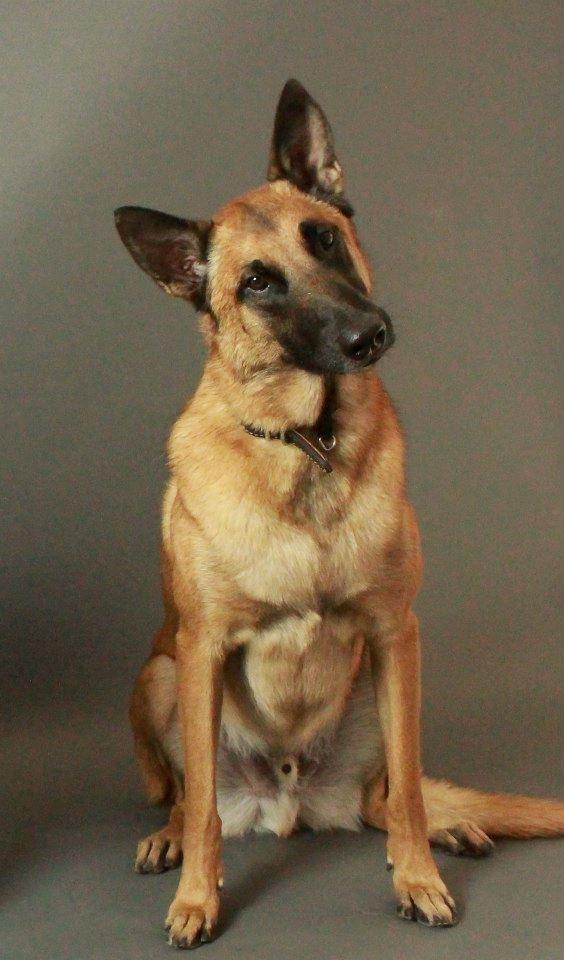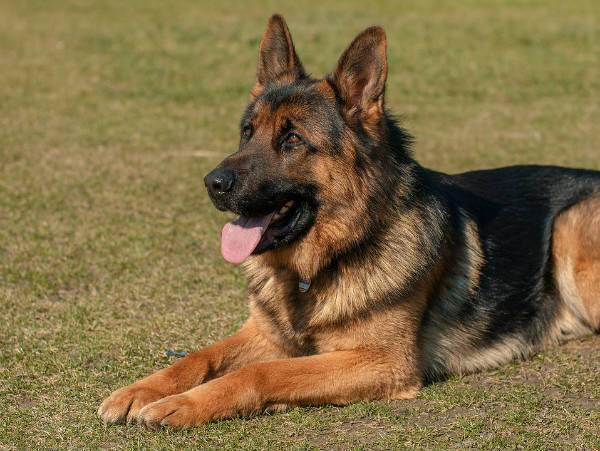The first image is the image on the left, the second image is the image on the right. For the images displayed, is the sentence "Left image features a german shepherd sitting upright outdoors." factually correct? Answer yes or no. No. The first image is the image on the left, the second image is the image on the right. Given the left and right images, does the statement "At least one dog has its tongue out." hold true? Answer yes or no. Yes. 